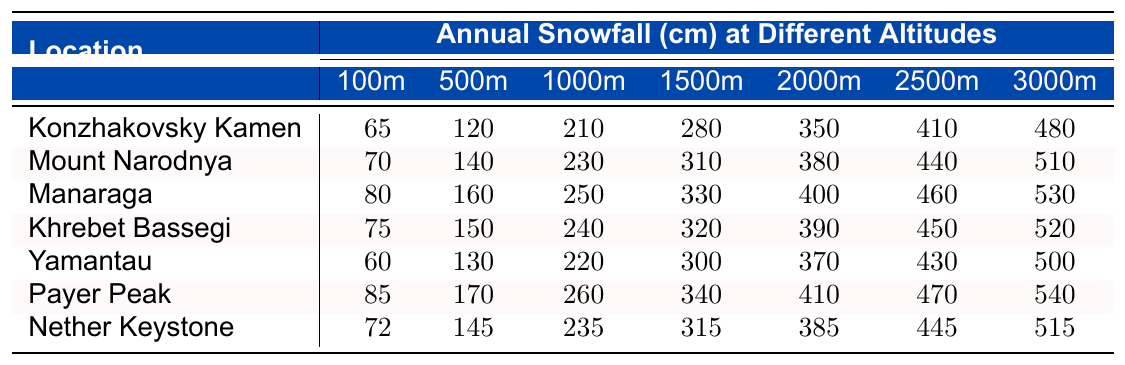What is the annual snowfall at 2000 meters altitude for Yamantau? Referring to the table, for Yamantau at an altitude of 2000 meters, the annual snowfall measurement is 370 cm.
Answer: 370 cm Which location has the highest annual snowfall at 1500 meters? Looking at the 1500-meter row, Payer Peak has the highest annual snowfall at 340 cm.
Answer: Payer Peak What is the difference in annual snowfall between Konzhakovsky Kamen at 1000 meters and Khrebet Bassegi at the same altitude? The snowfall at Konzhakovsky Kamen at 1000 meters is 210 cm, while at Khrebet Bassegi, it's 240 cm. The difference is 240 - 210 = 30 cm.
Answer: 30 cm Is the annual snowfall at 3000 meters altitude for Manaraga higher than that for Mount Narodnya? Checking the table, Manaraga has 530 cm at 3000 meters, while Mount Narodnya has 510 cm. Therefore, the statement is true.
Answer: Yes What is the average annual snowfall at 1000 meters across all locations? To find the average at 1000 meters, sum the values: 210 + 230 + 250 + 240 + 220 + 260 + 235 = 1685 cm. There are 7 locations, so the average is 1685 / 7 ≈ 240.71 cm.
Answer: 240.71 cm Which altitude shows the greatest variation in annual snowfall measurements? To determine this, find the max and min annual snowfall for each altitude. At 1000 meters, the maximum is 260 cm and minimum is 210 cm; variation = 50 cm. Calculate similarly for other altitudes, finding the greatest variation at 3000 meters (540 cm - 480 cm = 60 cm).
Answer: 3000 meters In total, how much annual snowfall does Payer Peak receive at all altitudes combined? Summing Payer Peak's annual snowfall measurements: 85 + 170 + 260 + 340 + 410 + 470 + 540 = 1875 cm gives the total.
Answer: 1875 cm At which altitude does Nether Keystone have the lowest snowfall, and what is that measurement? Checking the Nether Keystone row, the snowfall is lowest at 100 meters with a measurement of 72 cm.
Answer: 72 cm How does the snowfall at 2500 meters altitude for Manaraga compare to that for Khrebet Bassegi? Manaraga has 460 cm of snowfall at 2500 meters, while Khrebet Bassegi has 450 cm, making Manaraga higher by 10 cm.
Answer: Manaraga is higher by 10 cm What is the total snowfall at 500 meters across all locations? Adding up the snowfall at 500 meters: 120 + 140 + 160 + 150 + 130 + 170 + 145 = 1075 cm. Thus, the total snowfall is 1075 cm.
Answer: 1075 cm 